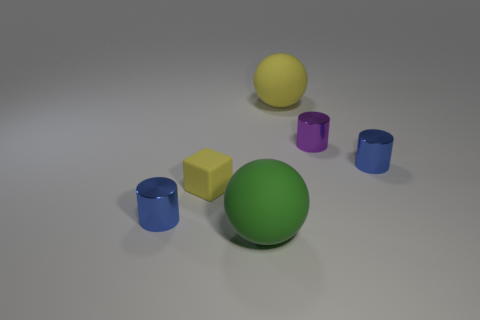Can you describe the spatial arrangement of the items in the picture? Certainly! The objects are spaced evenly across a flat surface. In the foreground, we have a large green sphere slightly to the right, paired with a smaller yellow cube to its left. In the midground, there are two blue cylindrical objects and one purple cylinder, all oriented vertically. Lastly, in the background, there's a yellow sphere centered between two other items. The arrangement creates a visually balanced composition with a pleasant variety of shapes and colors. 